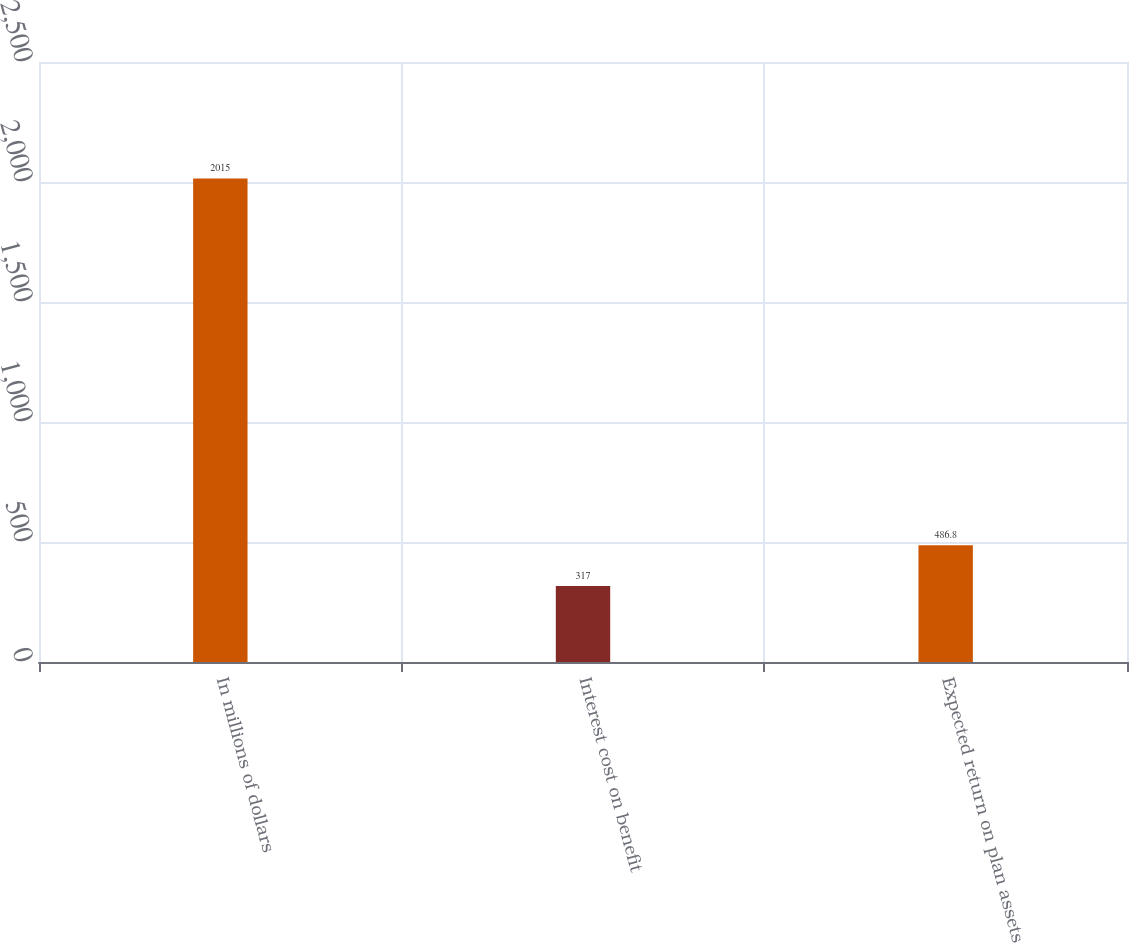<chart> <loc_0><loc_0><loc_500><loc_500><bar_chart><fcel>In millions of dollars<fcel>Interest cost on benefit<fcel>Expected return on plan assets<nl><fcel>2015<fcel>317<fcel>486.8<nl></chart> 